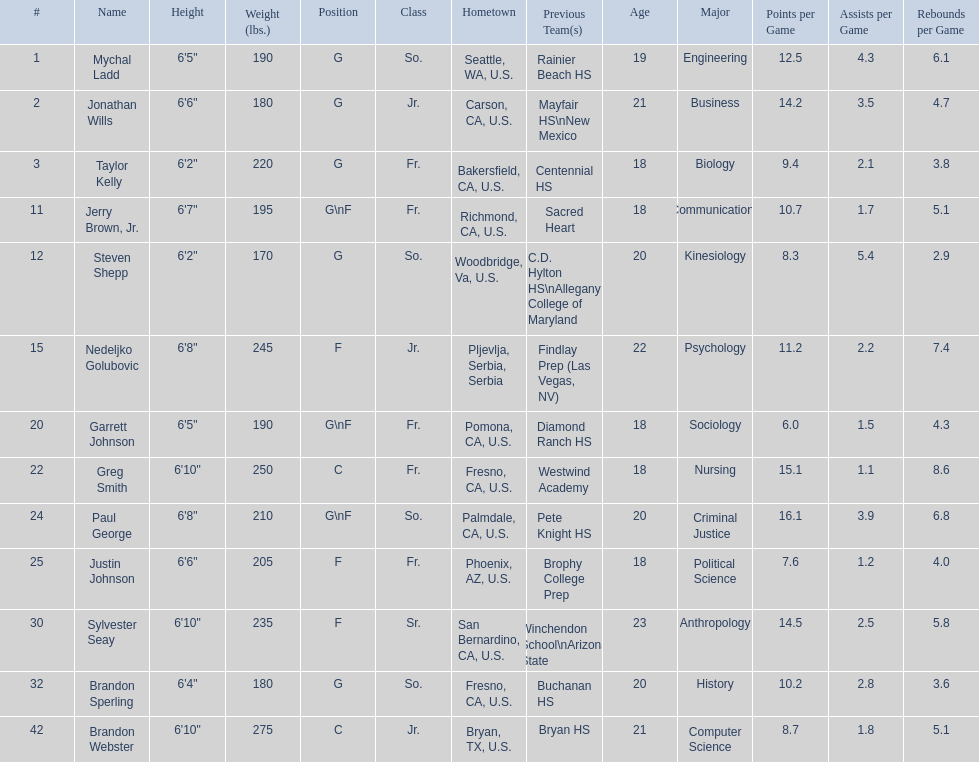Who are all the players? Mychal Ladd, Jonathan Wills, Taylor Kelly, Jerry Brown, Jr., Steven Shepp, Nedeljko Golubovic, Garrett Johnson, Greg Smith, Paul George, Justin Johnson, Sylvester Seay, Brandon Sperling, Brandon Webster. How tall are they? 6'5", 6'6", 6'2", 6'7", 6'2", 6'8", 6'5", 6'10", 6'8", 6'6", 6'10", 6'4", 6'10". What about just paul george and greg smitih? 6'10", 6'8". And which of the two is taller? Greg Smith. 